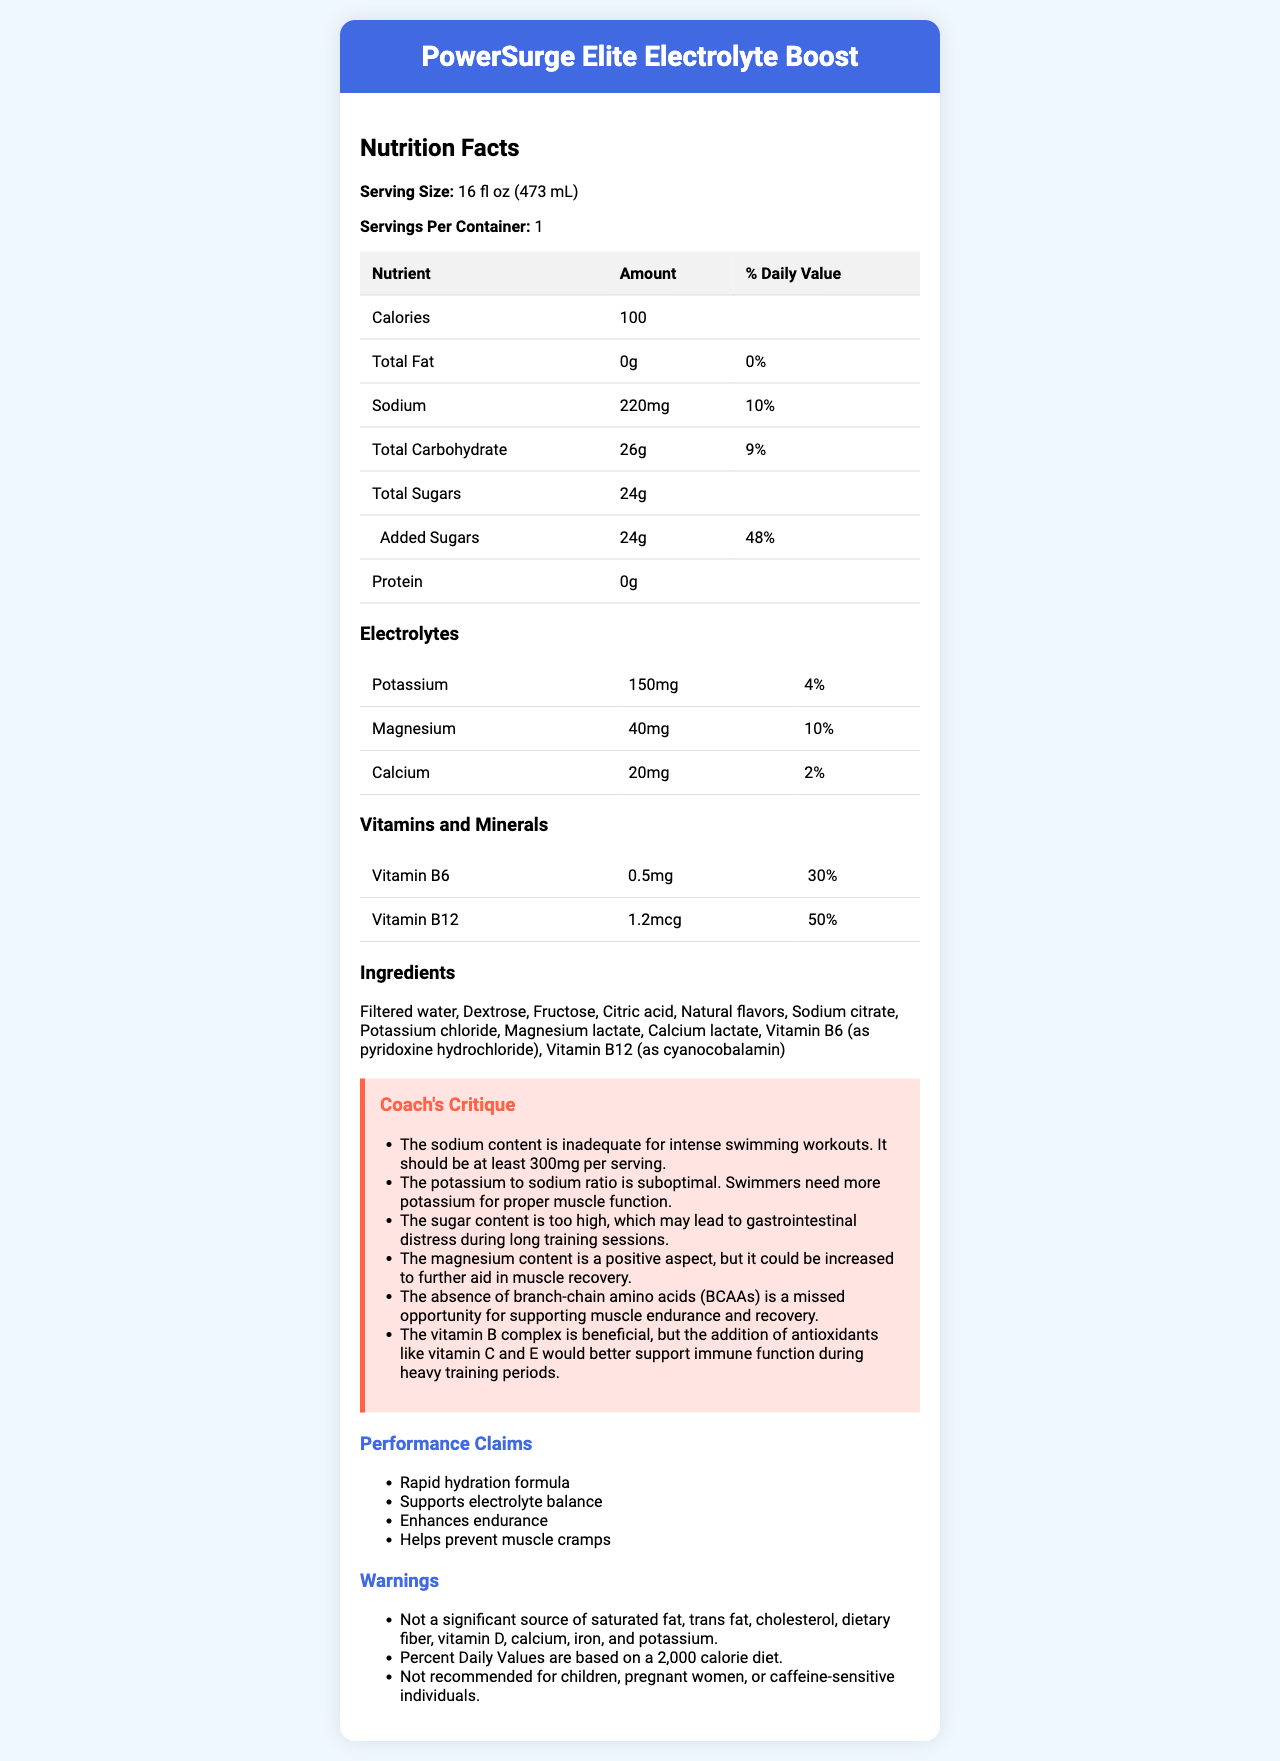what is the serving size? The serving size is listed as 16 fl oz (473 mL) in the document.
Answer: 16 fl oz (473 mL) how many servings are in a container? The document mentions there is 1 serving per container.
Answer: 1 how many calories are in one serving? The document states that one serving contains 100 calories.
Answer: 100 what is the amount of sodium per serving? The document notes that one serving contains 220mg of sodium.
Answer: 220mg how much protein does the drink contain? The document mentions that the drink contains 0g of protein.
Answer: 0g which electrolyte has the highest amount per serving? A. Potassium B. Magnesium C. Calcium Potassium has 150mg, which is more than Magnesium (40mg) and Calcium (20mg).
Answer: A. Potassium what is the percentage of daily value for added sugars? A. 24% B. 48% C. 9% D. 30% The document shows that the added sugars' percent daily value is 48%.
Answer: B. 48% are there any added sugars in this drink? The document lists "24g" of added sugars under the "total sugars" section.
Answer: Yes does the drink contain vitamin C? The document does not mention vitamin C in the vitamins and minerals section.
Answer: No summarize the electrolyte content of the drink The electrolyte section lists the amounts and percent daily values for Potassium, Magnesium, and Calcium.
Answer: The drink contains 150mg of Potassium (4% DV), 40mg of Magnesium (10% DV), and 20mg of Calcium (2% DV). how many grams of total carbohydrate are there per serving? The document states that there are 26g of total carbohydrates per serving.
Answer: 26g who should avoid drinking this product according to the warnings? A. Children B. Pregnant women C. Caffeine-sensitive individuals D. All of the above The warnings section states that children, pregnant women, and caffeine-sensitive individuals should avoid drinking this product.
Answer: D. All of the above is this drink a significant source of dietary fiber? The warnings mentioned that it is not a significant source of dietary fiber.
Answer: No what is the critique about the sugar content? The coach's critique section specifically mentions the high sugar content as a concern for gastrointestinal distress.
Answer: The sugar content is too high, which may lead to gastrointestinal distress during long training sessions. what vitamins are included in the drink? The vitamins and minerals section mentions Vitamin B6 (0.5mg) and Vitamin B12 (1.2mcg).
Answer: Vitamin B6 and Vitamin B12 what is the suggested improvement regarding sodium content? The coach's critique advises that the sodium content is inadequate and should be increased to at least 300mg per serving.
Answer: The sodium content should be at least 300mg per serving. what are the performance claims mentioned? The document lists these performance claims in the performance claims section.
Answer: Rapid hydration formula, Supports electrolyte balance, Enhances endurance, Helps prevent muscle cramps what is the main idea of the document? The document details the nutritional content and other relevant information about the sports energy drink, highlighting both its benefits and areas for improvement.
Answer: The document provides detailed nutrition facts for the sports energy drink "PowerSurge Elite Electrolyte Boost," including nutrient content, electrolytes, vitamins, ingredients, and contains critiques and suggestions from a swimming coach. does the energy drink contain caffeine? The document does not mention caffeine anywhere in the ingredients, nutrition facts, or warnings.
Answer: Not enough information what is the potassium to sodium ratio? The document lists 150mg of Potassium and 220mg of Sodium, resulting in a ratio of approximately 0.68:1.
Answer: 0.68:1 